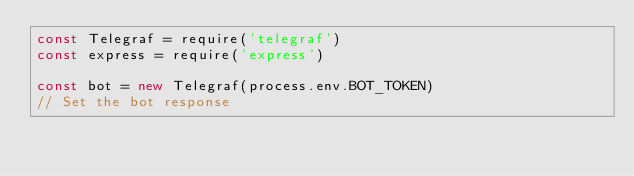<code> <loc_0><loc_0><loc_500><loc_500><_JavaScript_>const Telegraf = require('telegraf')
const express = require('express')

const bot = new Telegraf(process.env.BOT_TOKEN)
// Set the bot response</code> 